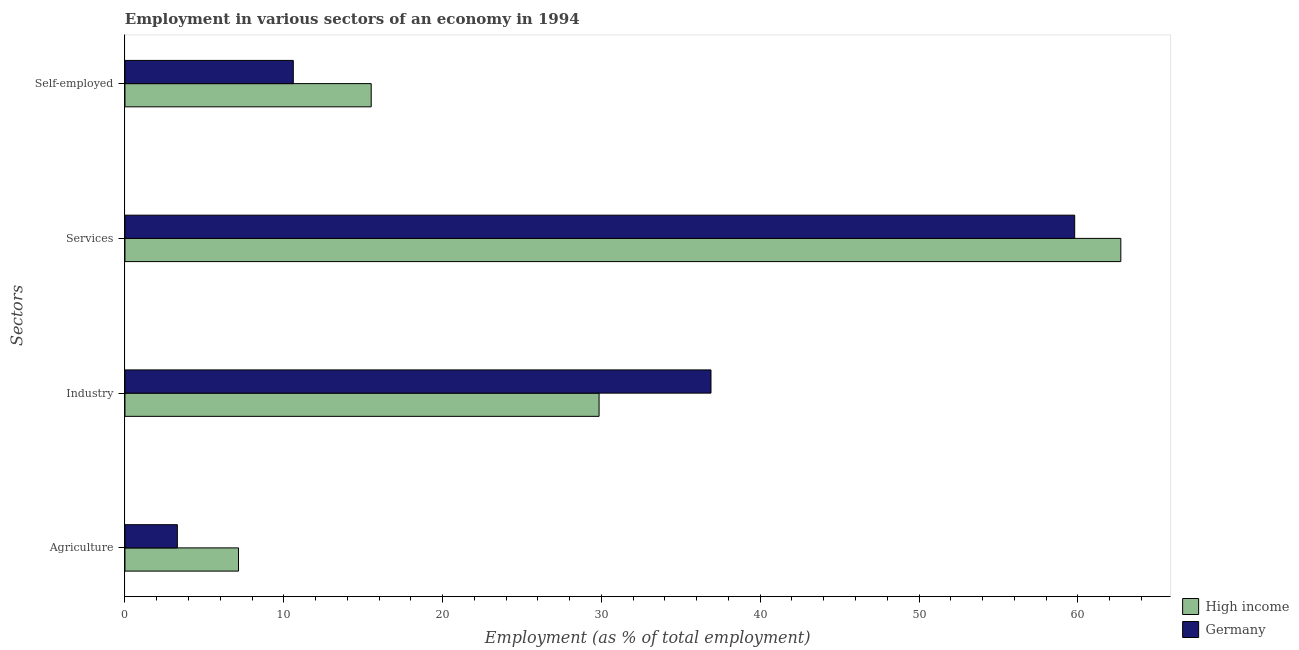Are the number of bars per tick equal to the number of legend labels?
Your answer should be compact. Yes. Are the number of bars on each tick of the Y-axis equal?
Offer a terse response. Yes. What is the label of the 4th group of bars from the top?
Your response must be concise. Agriculture. What is the percentage of workers in industry in High income?
Provide a short and direct response. 29.85. Across all countries, what is the maximum percentage of workers in agriculture?
Give a very brief answer. 7.15. Across all countries, what is the minimum percentage of workers in agriculture?
Offer a very short reply. 3.3. In which country was the percentage of workers in agriculture minimum?
Your answer should be compact. Germany. What is the total percentage of workers in agriculture in the graph?
Your answer should be very brief. 10.45. What is the difference between the percentage of workers in services in High income and that in Germany?
Your answer should be very brief. 2.91. What is the difference between the percentage of workers in agriculture in High income and the percentage of workers in industry in Germany?
Offer a very short reply. -29.75. What is the average percentage of workers in agriculture per country?
Offer a very short reply. 5.23. What is the difference between the percentage of workers in agriculture and percentage of self employed workers in Germany?
Your response must be concise. -7.3. What is the ratio of the percentage of workers in agriculture in Germany to that in High income?
Give a very brief answer. 0.46. Is the percentage of workers in agriculture in Germany less than that in High income?
Your answer should be very brief. Yes. Is the difference between the percentage of workers in industry in High income and Germany greater than the difference between the percentage of workers in agriculture in High income and Germany?
Your response must be concise. No. What is the difference between the highest and the second highest percentage of workers in agriculture?
Offer a very short reply. 3.85. What is the difference between the highest and the lowest percentage of workers in services?
Your response must be concise. 2.91. In how many countries, is the percentage of self employed workers greater than the average percentage of self employed workers taken over all countries?
Ensure brevity in your answer.  1. Is it the case that in every country, the sum of the percentage of workers in services and percentage of workers in industry is greater than the sum of percentage of workers in agriculture and percentage of self employed workers?
Offer a very short reply. Yes. What does the 2nd bar from the bottom in Self-employed represents?
Provide a short and direct response. Germany. Is it the case that in every country, the sum of the percentage of workers in agriculture and percentage of workers in industry is greater than the percentage of workers in services?
Offer a very short reply. No. How many bars are there?
Ensure brevity in your answer.  8. Are all the bars in the graph horizontal?
Make the answer very short. Yes. Where does the legend appear in the graph?
Your answer should be compact. Bottom right. What is the title of the graph?
Your answer should be compact. Employment in various sectors of an economy in 1994. What is the label or title of the X-axis?
Your response must be concise. Employment (as % of total employment). What is the label or title of the Y-axis?
Ensure brevity in your answer.  Sectors. What is the Employment (as % of total employment) of High income in Agriculture?
Offer a very short reply. 7.15. What is the Employment (as % of total employment) of Germany in Agriculture?
Your answer should be compact. 3.3. What is the Employment (as % of total employment) in High income in Industry?
Your response must be concise. 29.85. What is the Employment (as % of total employment) of Germany in Industry?
Make the answer very short. 36.9. What is the Employment (as % of total employment) in High income in Services?
Ensure brevity in your answer.  62.71. What is the Employment (as % of total employment) of Germany in Services?
Offer a very short reply. 59.8. What is the Employment (as % of total employment) in High income in Self-employed?
Provide a short and direct response. 15.51. What is the Employment (as % of total employment) of Germany in Self-employed?
Offer a terse response. 10.6. Across all Sectors, what is the maximum Employment (as % of total employment) in High income?
Offer a terse response. 62.71. Across all Sectors, what is the maximum Employment (as % of total employment) in Germany?
Give a very brief answer. 59.8. Across all Sectors, what is the minimum Employment (as % of total employment) in High income?
Provide a succinct answer. 7.15. Across all Sectors, what is the minimum Employment (as % of total employment) in Germany?
Provide a succinct answer. 3.3. What is the total Employment (as % of total employment) of High income in the graph?
Ensure brevity in your answer.  115.21. What is the total Employment (as % of total employment) of Germany in the graph?
Offer a very short reply. 110.6. What is the difference between the Employment (as % of total employment) in High income in Agriculture and that in Industry?
Offer a very short reply. -22.7. What is the difference between the Employment (as % of total employment) of Germany in Agriculture and that in Industry?
Offer a very short reply. -33.6. What is the difference between the Employment (as % of total employment) of High income in Agriculture and that in Services?
Offer a terse response. -55.55. What is the difference between the Employment (as % of total employment) of Germany in Agriculture and that in Services?
Keep it short and to the point. -56.5. What is the difference between the Employment (as % of total employment) in High income in Agriculture and that in Self-employed?
Make the answer very short. -8.36. What is the difference between the Employment (as % of total employment) in High income in Industry and that in Services?
Make the answer very short. -32.85. What is the difference between the Employment (as % of total employment) of Germany in Industry and that in Services?
Keep it short and to the point. -22.9. What is the difference between the Employment (as % of total employment) in High income in Industry and that in Self-employed?
Offer a very short reply. 14.35. What is the difference between the Employment (as % of total employment) in Germany in Industry and that in Self-employed?
Provide a short and direct response. 26.3. What is the difference between the Employment (as % of total employment) in High income in Services and that in Self-employed?
Your response must be concise. 47.2. What is the difference between the Employment (as % of total employment) in Germany in Services and that in Self-employed?
Provide a succinct answer. 49.2. What is the difference between the Employment (as % of total employment) of High income in Agriculture and the Employment (as % of total employment) of Germany in Industry?
Your answer should be very brief. -29.75. What is the difference between the Employment (as % of total employment) in High income in Agriculture and the Employment (as % of total employment) in Germany in Services?
Your answer should be compact. -52.65. What is the difference between the Employment (as % of total employment) of High income in Agriculture and the Employment (as % of total employment) of Germany in Self-employed?
Offer a terse response. -3.45. What is the difference between the Employment (as % of total employment) in High income in Industry and the Employment (as % of total employment) in Germany in Services?
Provide a short and direct response. -29.95. What is the difference between the Employment (as % of total employment) in High income in Industry and the Employment (as % of total employment) in Germany in Self-employed?
Keep it short and to the point. 19.25. What is the difference between the Employment (as % of total employment) in High income in Services and the Employment (as % of total employment) in Germany in Self-employed?
Ensure brevity in your answer.  52.11. What is the average Employment (as % of total employment) of High income per Sectors?
Provide a short and direct response. 28.8. What is the average Employment (as % of total employment) of Germany per Sectors?
Offer a terse response. 27.65. What is the difference between the Employment (as % of total employment) of High income and Employment (as % of total employment) of Germany in Agriculture?
Offer a terse response. 3.85. What is the difference between the Employment (as % of total employment) in High income and Employment (as % of total employment) in Germany in Industry?
Your response must be concise. -7.05. What is the difference between the Employment (as % of total employment) in High income and Employment (as % of total employment) in Germany in Services?
Give a very brief answer. 2.91. What is the difference between the Employment (as % of total employment) in High income and Employment (as % of total employment) in Germany in Self-employed?
Ensure brevity in your answer.  4.91. What is the ratio of the Employment (as % of total employment) of High income in Agriculture to that in Industry?
Ensure brevity in your answer.  0.24. What is the ratio of the Employment (as % of total employment) in Germany in Agriculture to that in Industry?
Ensure brevity in your answer.  0.09. What is the ratio of the Employment (as % of total employment) of High income in Agriculture to that in Services?
Your answer should be very brief. 0.11. What is the ratio of the Employment (as % of total employment) of Germany in Agriculture to that in Services?
Offer a very short reply. 0.06. What is the ratio of the Employment (as % of total employment) in High income in Agriculture to that in Self-employed?
Keep it short and to the point. 0.46. What is the ratio of the Employment (as % of total employment) in Germany in Agriculture to that in Self-employed?
Make the answer very short. 0.31. What is the ratio of the Employment (as % of total employment) in High income in Industry to that in Services?
Make the answer very short. 0.48. What is the ratio of the Employment (as % of total employment) in Germany in Industry to that in Services?
Provide a succinct answer. 0.62. What is the ratio of the Employment (as % of total employment) in High income in Industry to that in Self-employed?
Offer a terse response. 1.93. What is the ratio of the Employment (as % of total employment) of Germany in Industry to that in Self-employed?
Your answer should be very brief. 3.48. What is the ratio of the Employment (as % of total employment) of High income in Services to that in Self-employed?
Provide a succinct answer. 4.04. What is the ratio of the Employment (as % of total employment) in Germany in Services to that in Self-employed?
Your response must be concise. 5.64. What is the difference between the highest and the second highest Employment (as % of total employment) in High income?
Give a very brief answer. 32.85. What is the difference between the highest and the second highest Employment (as % of total employment) of Germany?
Your response must be concise. 22.9. What is the difference between the highest and the lowest Employment (as % of total employment) of High income?
Provide a short and direct response. 55.55. What is the difference between the highest and the lowest Employment (as % of total employment) in Germany?
Give a very brief answer. 56.5. 